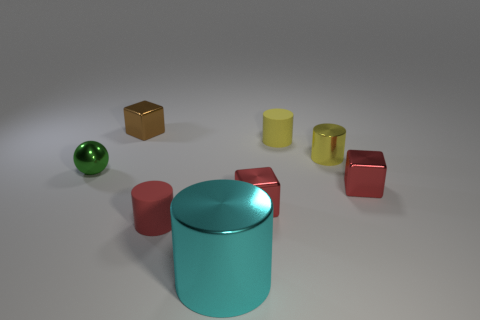Subtract all blue cubes. Subtract all blue cylinders. How many cubes are left? 3 Add 2 small shiny blocks. How many objects exist? 10 Subtract all balls. How many objects are left? 7 Subtract all large rubber cylinders. Subtract all red things. How many objects are left? 5 Add 8 big metallic cylinders. How many big metallic cylinders are left? 9 Add 5 tiny green balls. How many tiny green balls exist? 6 Subtract 0 purple balls. How many objects are left? 8 